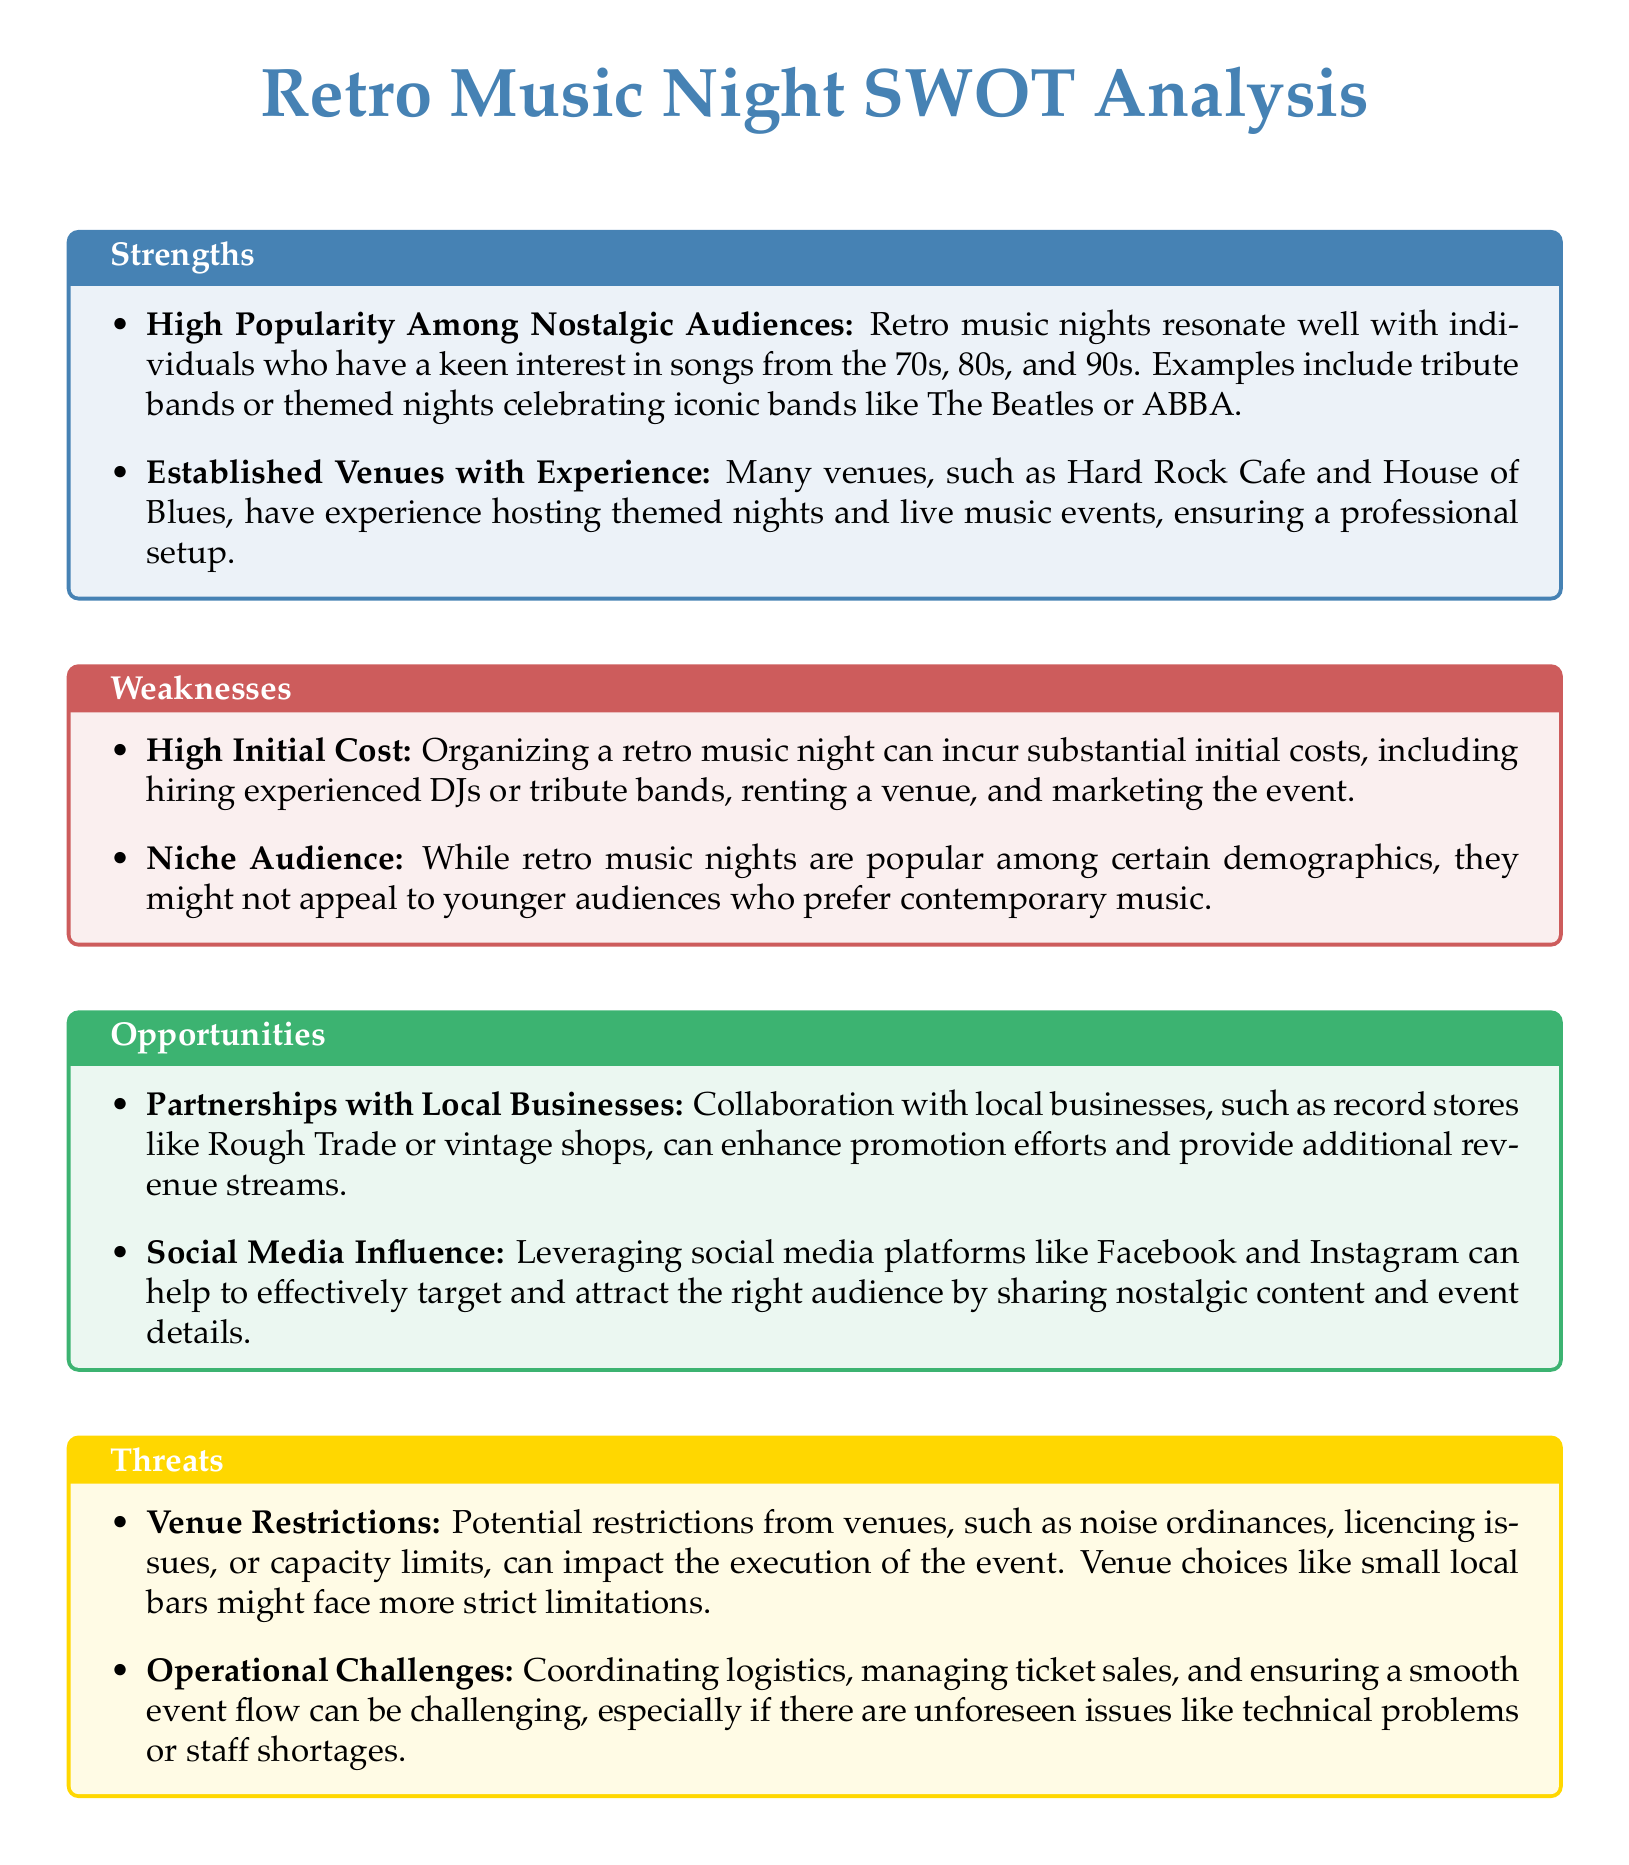What are the established venues mentioned? The document lists venues like Hard Rock Cafe and House of Blues as examples of established venues with experience hosting themed nights.
Answer: Hard Rock Cafe, House of Blues What is a key strength of retro music nights? The document states that retro music nights resonate well with individuals who have a keen interest in songs from the 70s, 80s, and 90s.
Answer: High Popularity Among Nostalgic Audiences What is one of the weaknesses related to the audience? The document mentions that retro music nights might not appeal to younger audiences who prefer contemporary music.
Answer: Niche Audience What opportunity involves local businesses? The document highlights the potential for partnerships with local businesses to enhance promotion efforts and provide additional revenue streams.
Answer: Partnerships with Local Businesses What is a threat associated with venue restrictions? The document specifies that potential restrictions from venues can impact the execution of the event, mentioning noise ordinances and licensing issues.
Answer: Venue Restrictions What is the initial cost concern mentioned? The SWOT analysis points out that organizing a retro music night can incur substantial initial costs.
Answer: High Initial Cost What social media platform is suggested for promotion? The document suggests using social media platforms like Facebook and Instagram for effectively targeting and attracting the audience.
Answer: Facebook, Instagram What operational challenge is highlighted? The document mentions that coordinating logistics and managing ticket sales are operational challenges that can be problematic.
Answer: Operational Challenges 